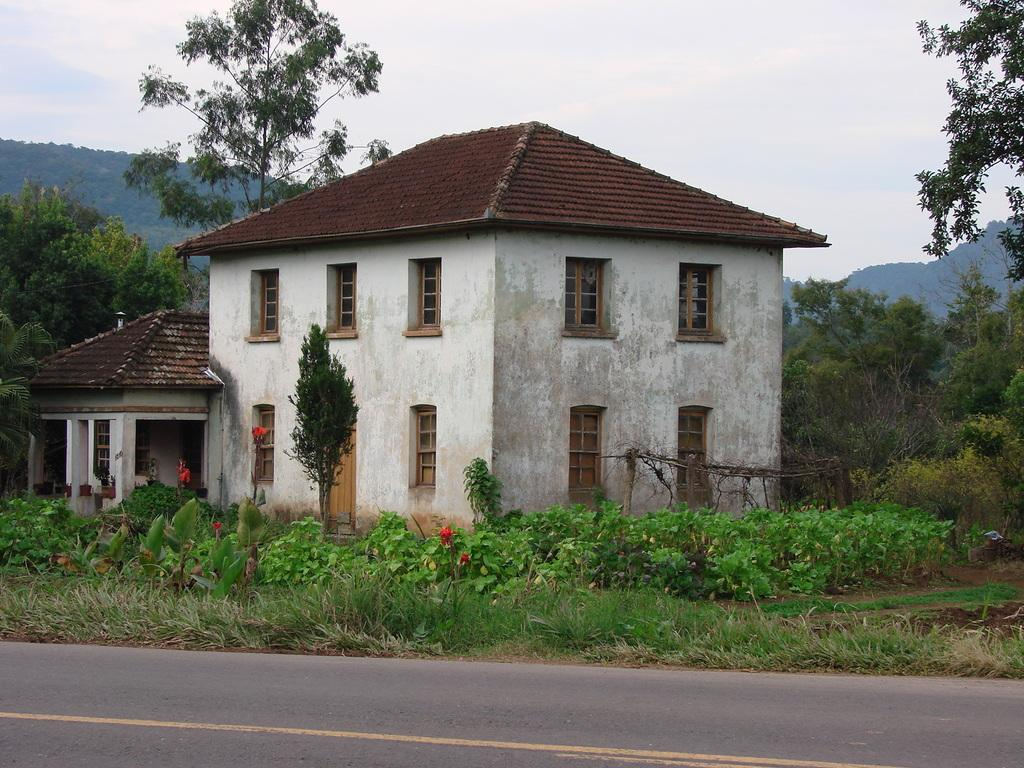What type of structure is present in the image? There is a building with windows in the image. What can be seen on the ground in the image? The ground with grass is visible in the image. What type of vegetation is present in the image? There are plants and trees in the image. What geographical feature is visible in the image? There are mountains in the image. What is visible in the sky in the image? The sky with clouds is visible in the image. How many cats are sitting on the coat in the image? There are no cats or coats present in the image. 